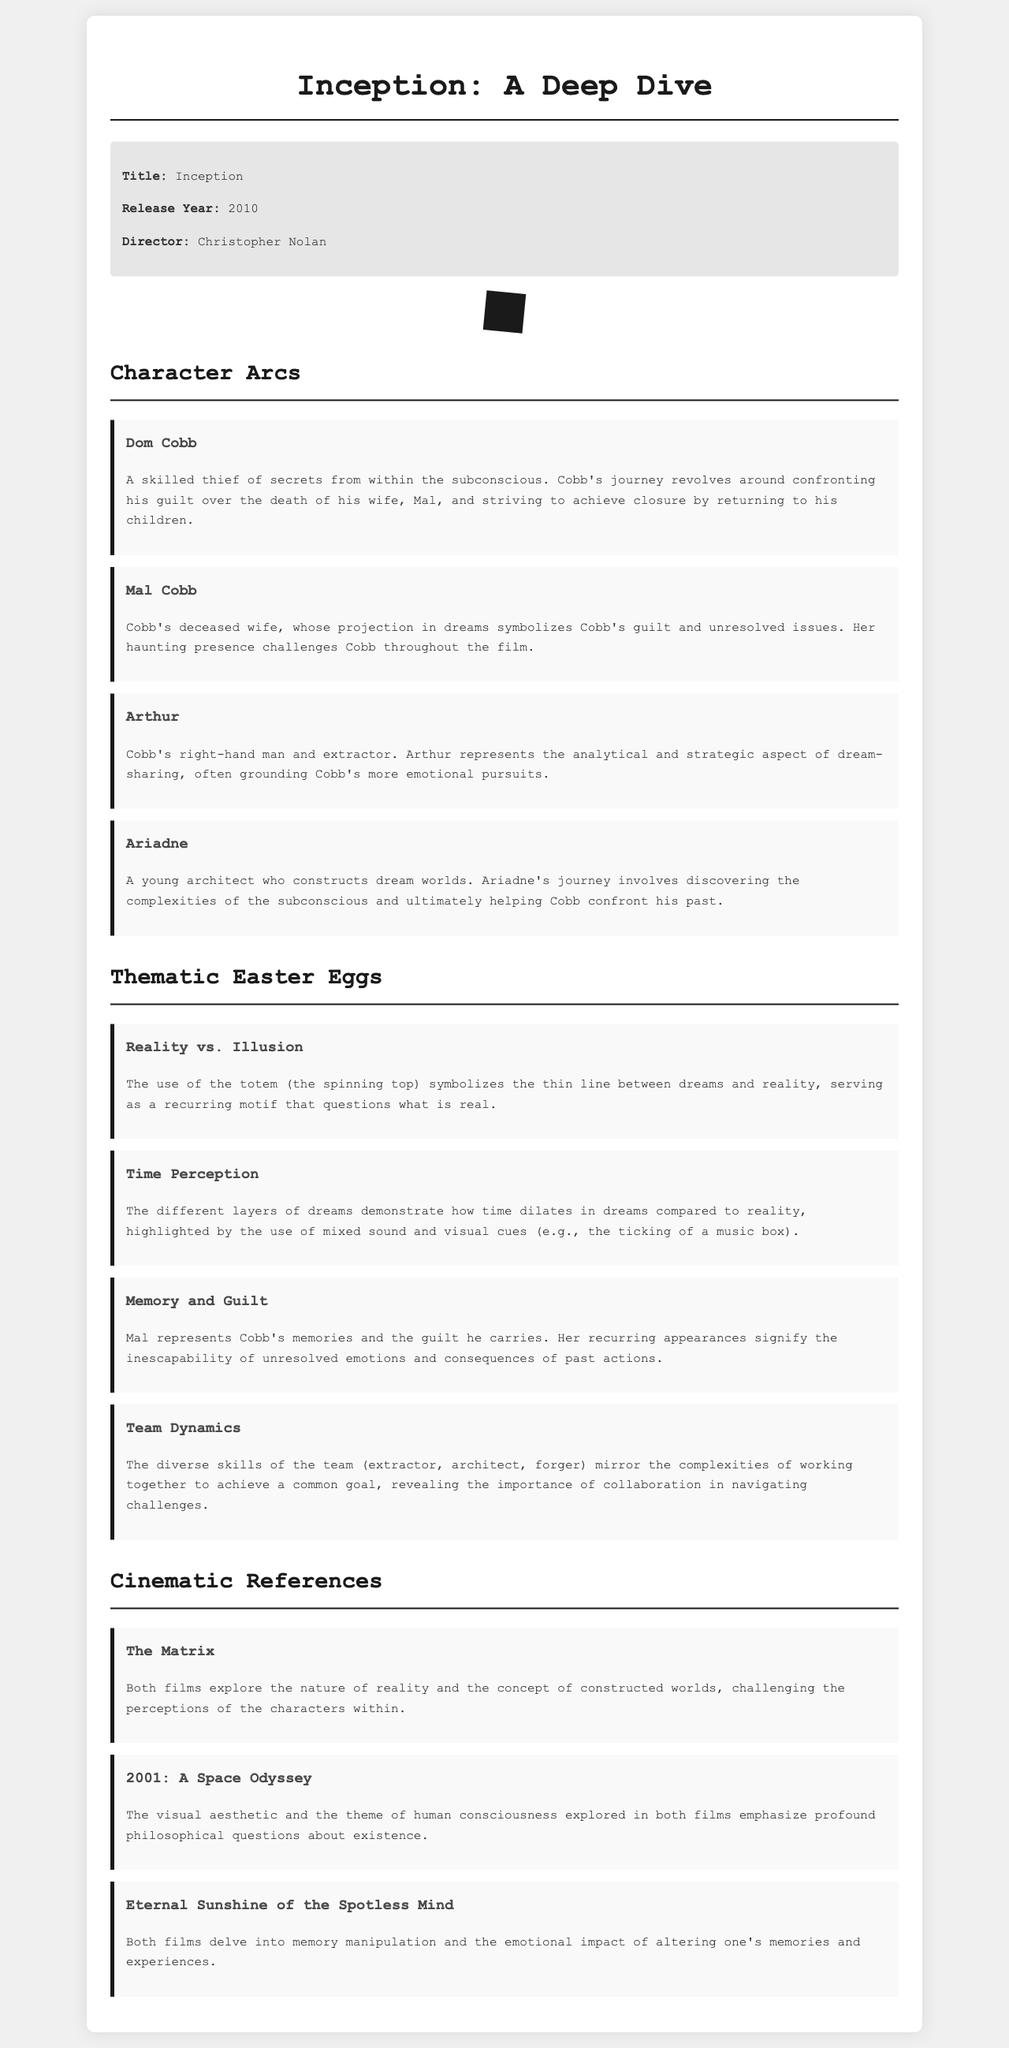What is the title of the film? The title of the film is presented at the beginning of the document.
Answer: Inception Who directed the movie? The director's name is mentioned in the movie information section.
Answer: Christopher Nolan What year was the film released? The release year is provided alongside the title in the document.
Answer: 2010 What is Dom Cobb's main struggle? Dom Cobb's journey revolves around confronting his guilt over his wife's death.
Answer: Guilt Which character represents the analytical aspect of dream-sharing? Arthur's role as Cobb's right-hand man highlights his analytical traits.
Answer: Arthur What motif symbolizes the thin line between dreams and reality? The document mentions a specific object that serves as a motif throughout the film.
Answer: Spinning top Which theme is embodied by the character Mal? Mal symbolizes Cobb's unresolved emotions and guilt throughout the film.
Answer: Memory and Guilt What cinematic reference also explores the nature of reality? One film mentioned shares a thematic connection with "Inception" regarding reality.
Answer: The Matrix How does time perception differ in dreams according to the film? It is explained in relation to the experience of time in different layers of dreams.
Answer: Dilates 